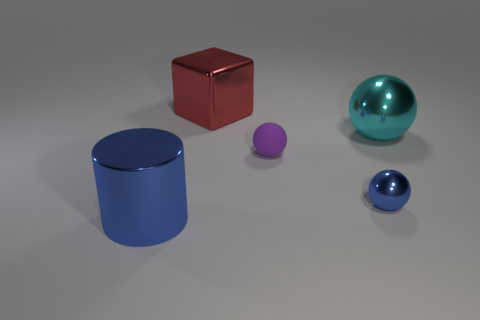Subtract all large metallic balls. How many balls are left? 2 Add 2 red cubes. How many objects exist? 7 Subtract all balls. How many objects are left? 2 Subtract all yellow spheres. Subtract all red blocks. How many spheres are left? 3 Add 2 big cyan objects. How many big cyan objects exist? 3 Subtract 0 yellow blocks. How many objects are left? 5 Subtract all tiny purple cubes. Subtract all red metal cubes. How many objects are left? 4 Add 3 red shiny things. How many red shiny things are left? 4 